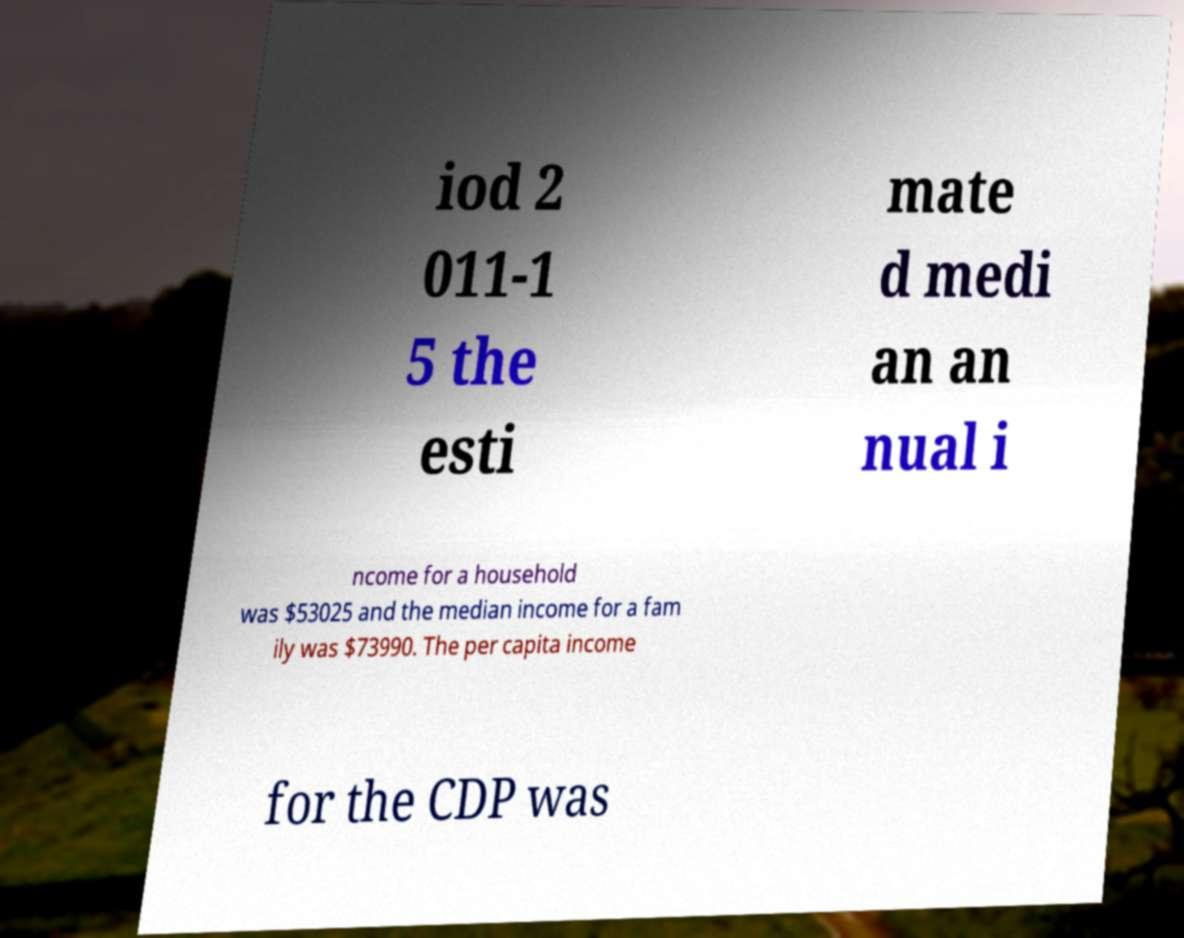Could you extract and type out the text from this image? iod 2 011-1 5 the esti mate d medi an an nual i ncome for a household was $53025 and the median income for a fam ily was $73990. The per capita income for the CDP was 